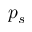Convert formula to latex. <formula><loc_0><loc_0><loc_500><loc_500>p _ { s }</formula> 